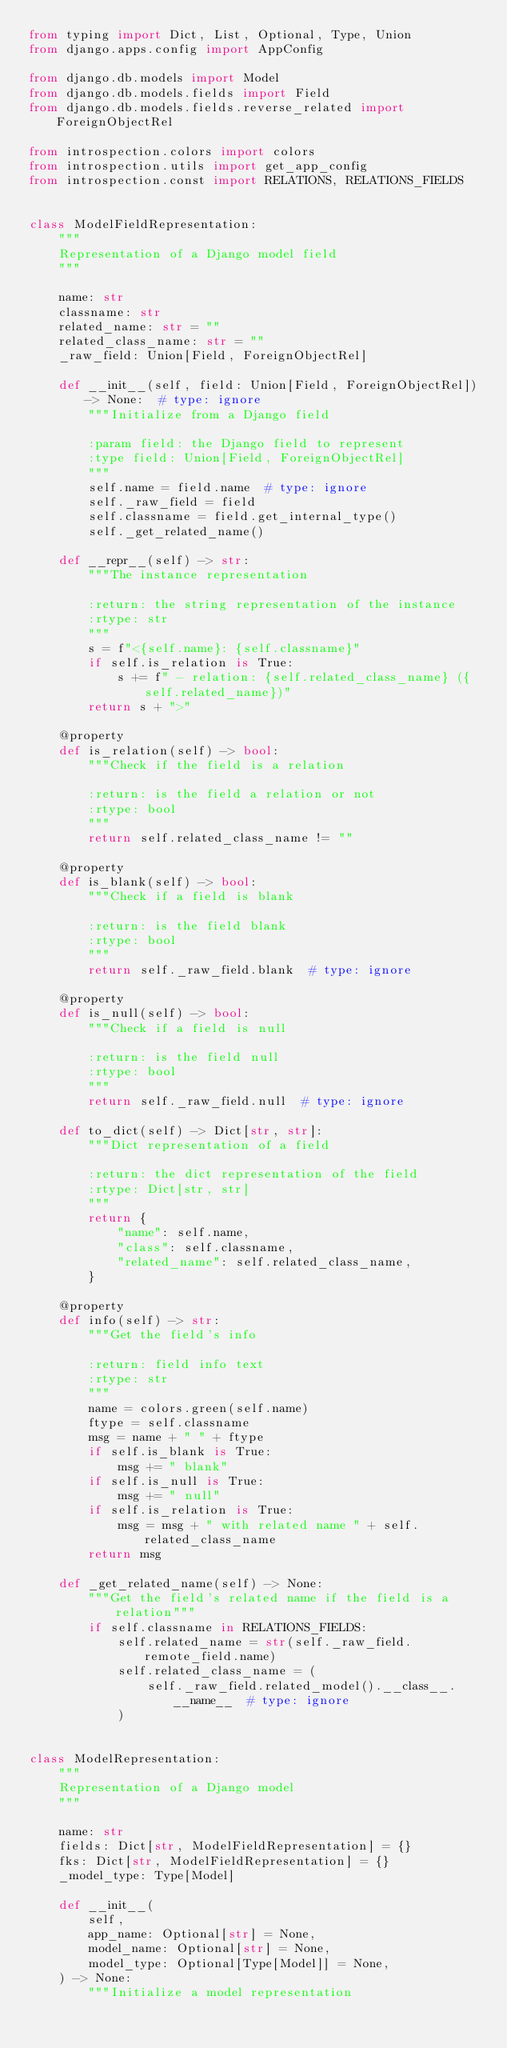<code> <loc_0><loc_0><loc_500><loc_500><_Python_>from typing import Dict, List, Optional, Type, Union
from django.apps.config import AppConfig

from django.db.models import Model
from django.db.models.fields import Field
from django.db.models.fields.reverse_related import ForeignObjectRel

from introspection.colors import colors
from introspection.utils import get_app_config
from introspection.const import RELATIONS, RELATIONS_FIELDS


class ModelFieldRepresentation:
    """
    Representation of a Django model field
    """

    name: str
    classname: str
    related_name: str = ""
    related_class_name: str = ""
    _raw_field: Union[Field, ForeignObjectRel]

    def __init__(self, field: Union[Field, ForeignObjectRel]) -> None:  # type: ignore
        """Initialize from a Django field

        :param field: the Django field to represent
        :type field: Union[Field, ForeignObjectRel]
        """
        self.name = field.name  # type: ignore
        self._raw_field = field
        self.classname = field.get_internal_type()
        self._get_related_name()

    def __repr__(self) -> str:
        """The instance representation

        :return: the string representation of the instance
        :rtype: str
        """
        s = f"<{self.name}: {self.classname}"
        if self.is_relation is True:
            s += f" - relation: {self.related_class_name} ({self.related_name})"
        return s + ">"

    @property
    def is_relation(self) -> bool:
        """Check if the field is a relation

        :return: is the field a relation or not
        :rtype: bool
        """
        return self.related_class_name != ""

    @property
    def is_blank(self) -> bool:
        """Check if a field is blank

        :return: is the field blank
        :rtype: bool
        """
        return self._raw_field.blank  # type: ignore

    @property
    def is_null(self) -> bool:
        """Check if a field is null

        :return: is the field null
        :rtype: bool
        """
        return self._raw_field.null  # type: ignore

    def to_dict(self) -> Dict[str, str]:
        """Dict representation of a field

        :return: the dict representation of the field
        :rtype: Dict[str, str]
        """
        return {
            "name": self.name,
            "class": self.classname,
            "related_name": self.related_class_name,
        }

    @property
    def info(self) -> str:
        """Get the field's info

        :return: field info text
        :rtype: str
        """
        name = colors.green(self.name)
        ftype = self.classname
        msg = name + " " + ftype
        if self.is_blank is True:
            msg += " blank"
        if self.is_null is True:
            msg += " null"
        if self.is_relation is True:
            msg = msg + " with related name " + self.related_class_name
        return msg

    def _get_related_name(self) -> None:
        """Get the field's related name if the field is a relation"""
        if self.classname in RELATIONS_FIELDS:
            self.related_name = str(self._raw_field.remote_field.name)
            self.related_class_name = (
                self._raw_field.related_model().__class__.__name__  # type: ignore
            )


class ModelRepresentation:
    """
    Representation of a Django model
    """

    name: str
    fields: Dict[str, ModelFieldRepresentation] = {}
    fks: Dict[str, ModelFieldRepresentation] = {}
    _model_type: Type[Model]

    def __init__(
        self,
        app_name: Optional[str] = None,
        model_name: Optional[str] = None,
        model_type: Optional[Type[Model]] = None,
    ) -> None:
        """Initialize a model representation
</code> 